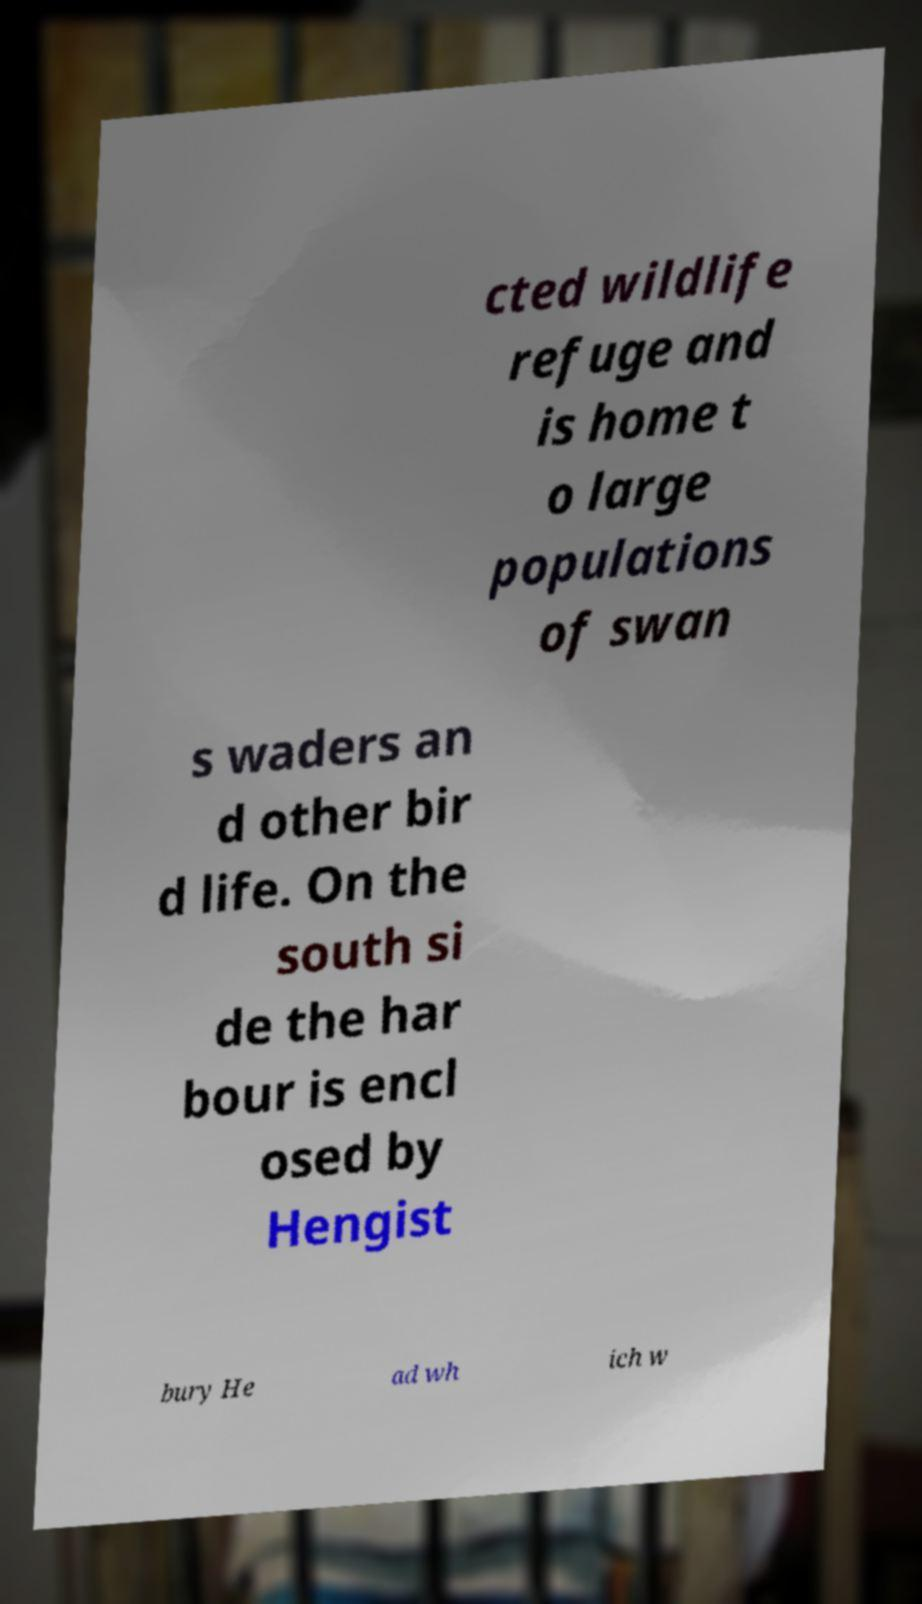For documentation purposes, I need the text within this image transcribed. Could you provide that? cted wildlife refuge and is home t o large populations of swan s waders an d other bir d life. On the south si de the har bour is encl osed by Hengist bury He ad wh ich w 